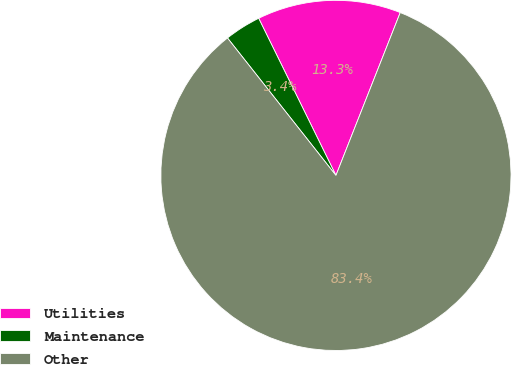Convert chart. <chart><loc_0><loc_0><loc_500><loc_500><pie_chart><fcel>Utilities<fcel>Maintenance<fcel>Other<nl><fcel>13.26%<fcel>3.36%<fcel>83.39%<nl></chart> 